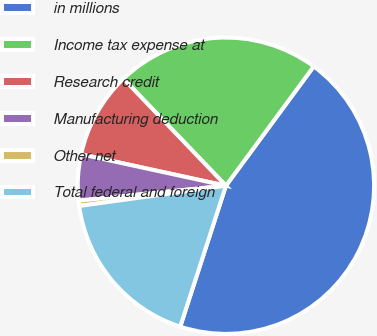Convert chart. <chart><loc_0><loc_0><loc_500><loc_500><pie_chart><fcel>in millions<fcel>Income tax expense at<fcel>Research credit<fcel>Manufacturing deduction<fcel>Other net<fcel>Total federal and foreign<nl><fcel>44.89%<fcel>22.25%<fcel>9.44%<fcel>5.01%<fcel>0.58%<fcel>17.82%<nl></chart> 